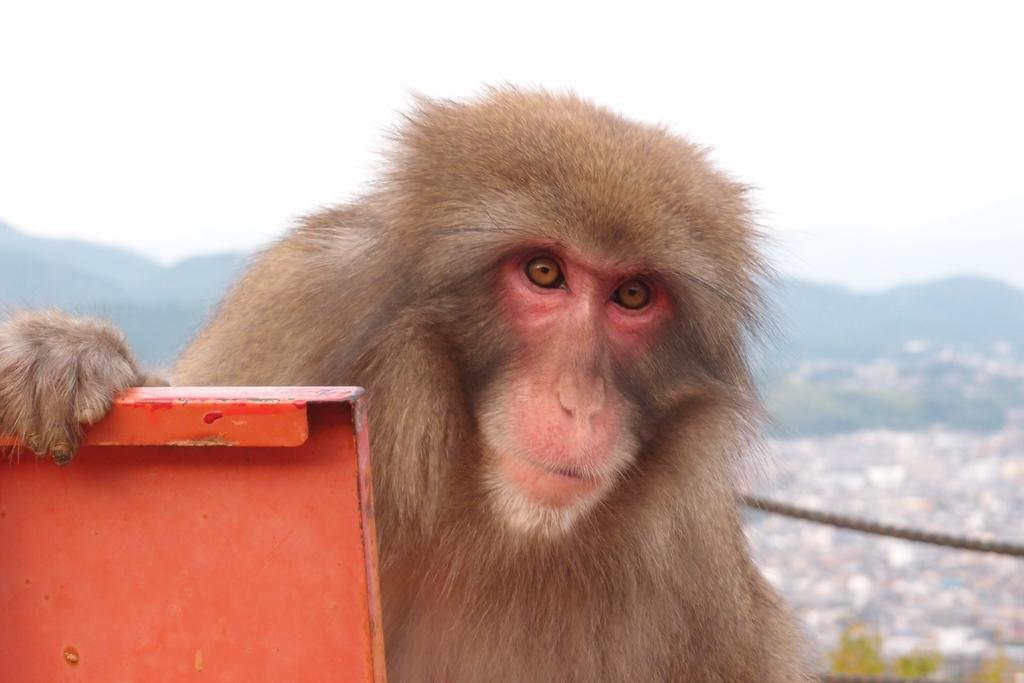What is the main subject in the center of the image? There is a monkey in the center of the image. What can be seen on the left side of the image? There is a board on the left side of the image. What type of punishment is the crow receiving in the image? There is there a crow present in the image? 